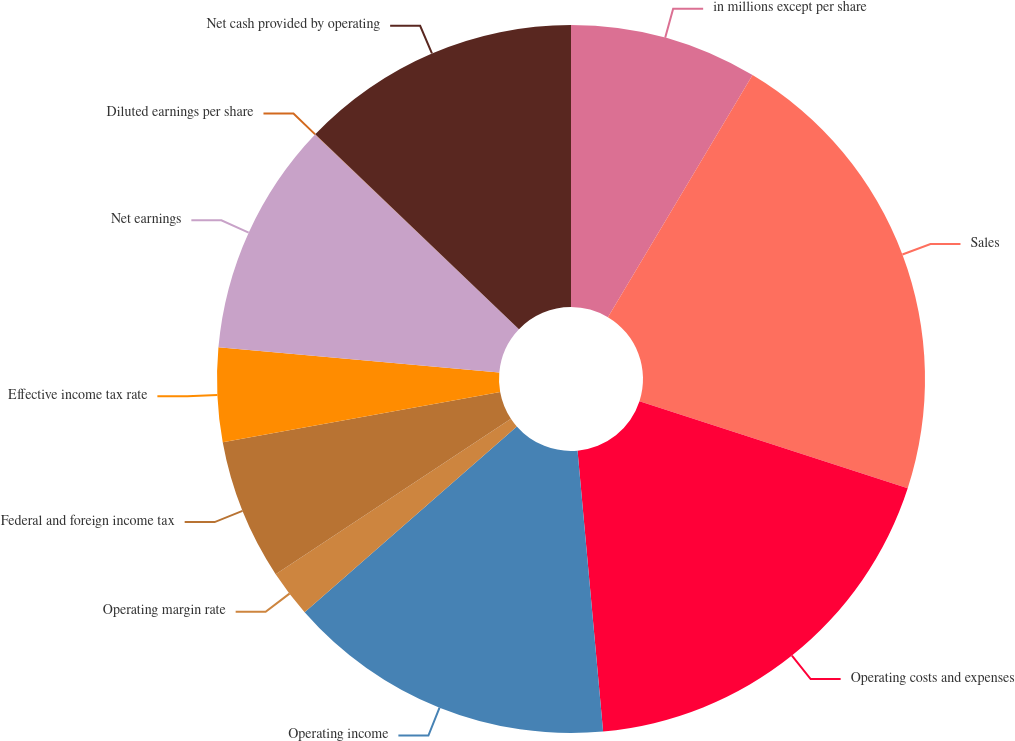<chart> <loc_0><loc_0><loc_500><loc_500><pie_chart><fcel>in millions except per share<fcel>Sales<fcel>Operating costs and expenses<fcel>Operating income<fcel>Operating margin rate<fcel>Federal and foreign income tax<fcel>Effective income tax rate<fcel>Net earnings<fcel>Diluted earnings per share<fcel>Net cash provided by operating<nl><fcel>8.57%<fcel>21.42%<fcel>18.56%<fcel>15.0%<fcel>2.15%<fcel>6.43%<fcel>4.29%<fcel>10.71%<fcel>0.01%<fcel>12.85%<nl></chart> 